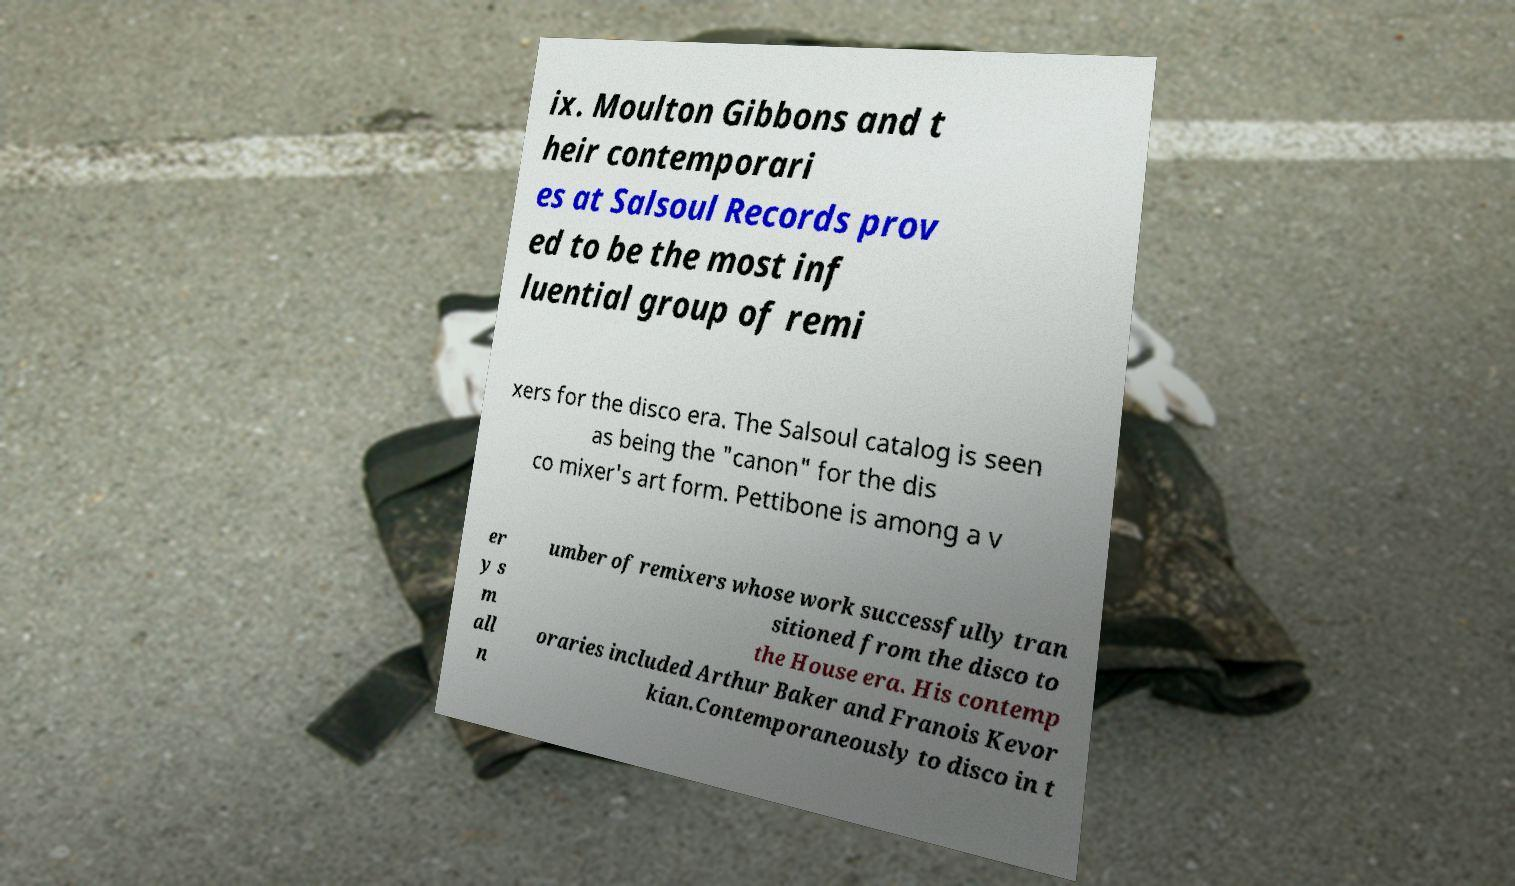I need the written content from this picture converted into text. Can you do that? ix. Moulton Gibbons and t heir contemporari es at Salsoul Records prov ed to be the most inf luential group of remi xers for the disco era. The Salsoul catalog is seen as being the "canon" for the dis co mixer's art form. Pettibone is among a v er y s m all n umber of remixers whose work successfully tran sitioned from the disco to the House era. His contemp oraries included Arthur Baker and Franois Kevor kian.Contemporaneously to disco in t 